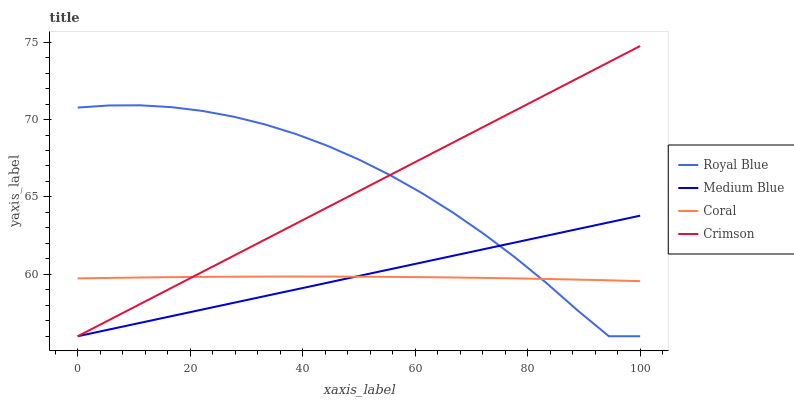Does Coral have the minimum area under the curve?
Answer yes or no. Yes. Does Royal Blue have the maximum area under the curve?
Answer yes or no. Yes. Does Royal Blue have the minimum area under the curve?
Answer yes or no. No. Does Coral have the maximum area under the curve?
Answer yes or no. No. Is Medium Blue the smoothest?
Answer yes or no. Yes. Is Royal Blue the roughest?
Answer yes or no. Yes. Is Coral the smoothest?
Answer yes or no. No. Is Coral the roughest?
Answer yes or no. No. Does Crimson have the lowest value?
Answer yes or no. Yes. Does Coral have the lowest value?
Answer yes or no. No. Does Crimson have the highest value?
Answer yes or no. Yes. Does Royal Blue have the highest value?
Answer yes or no. No. Does Coral intersect Medium Blue?
Answer yes or no. Yes. Is Coral less than Medium Blue?
Answer yes or no. No. Is Coral greater than Medium Blue?
Answer yes or no. No. 